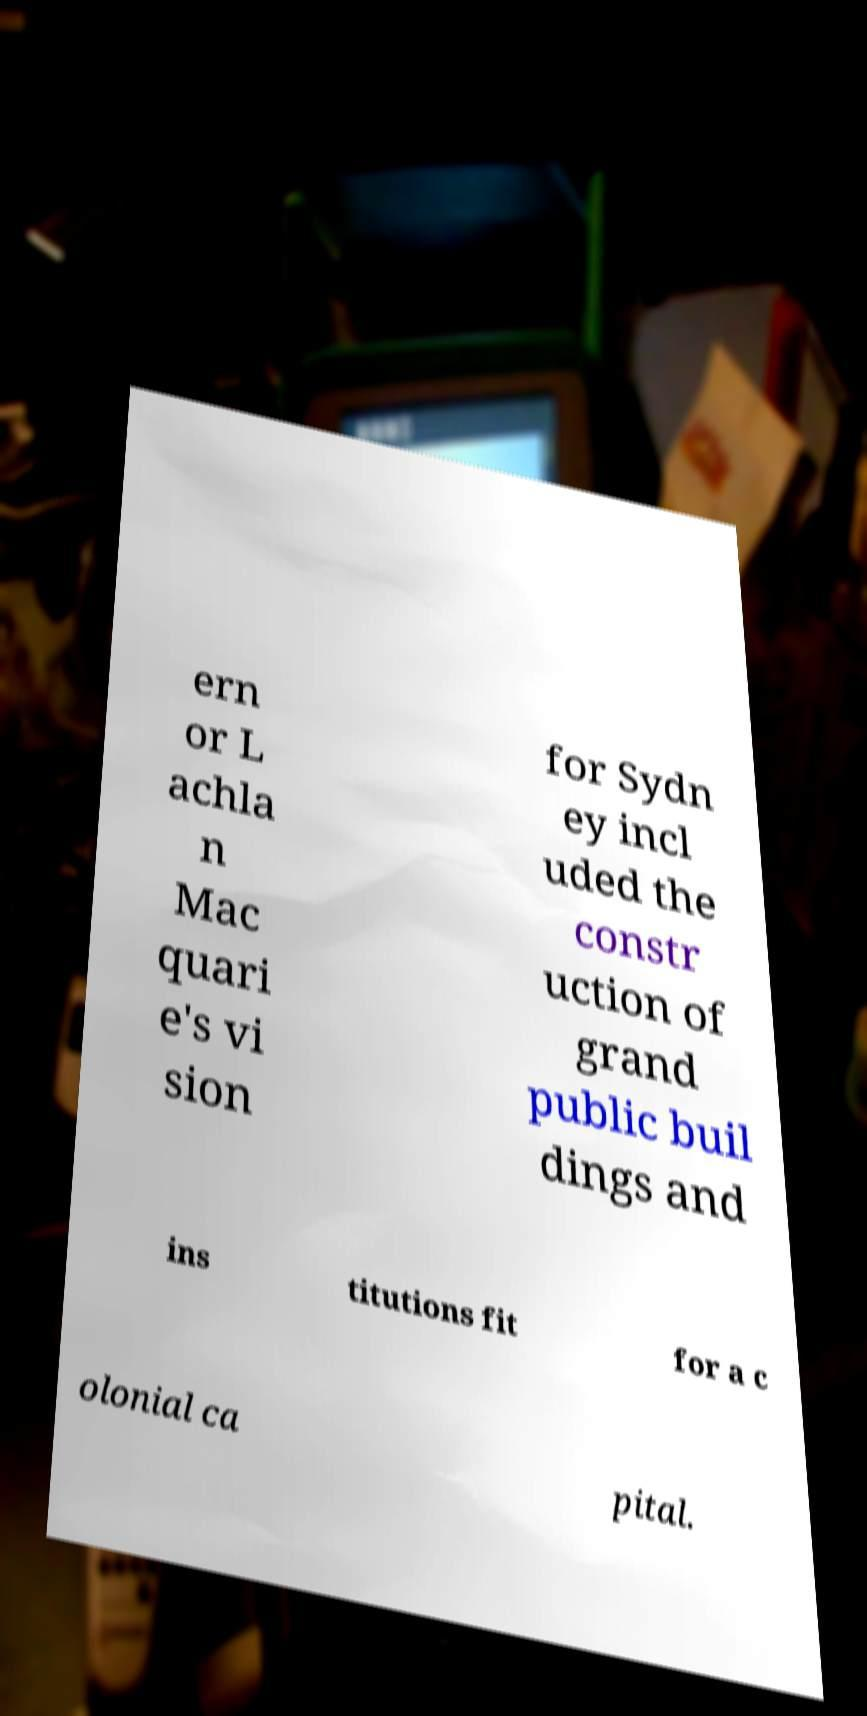I need the written content from this picture converted into text. Can you do that? ern or L achla n Mac quari e's vi sion for Sydn ey incl uded the constr uction of grand public buil dings and ins titutions fit for a c olonial ca pital. 